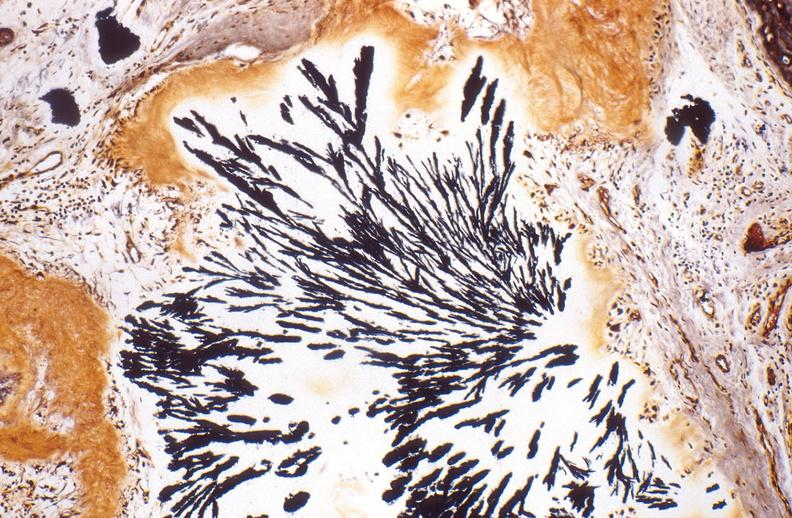does metastatic carcinoma lung show gout, alcohol fixed tissues, monosodium urate crystals?
Answer the question using a single word or phrase. No 